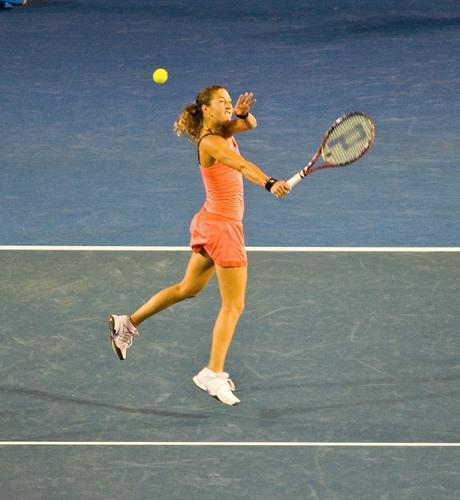Who supplied her tennis racket?
Make your selection from the four choices given to correctly answer the question.
Options: Wilson, nike, prince, puma. Prince. 